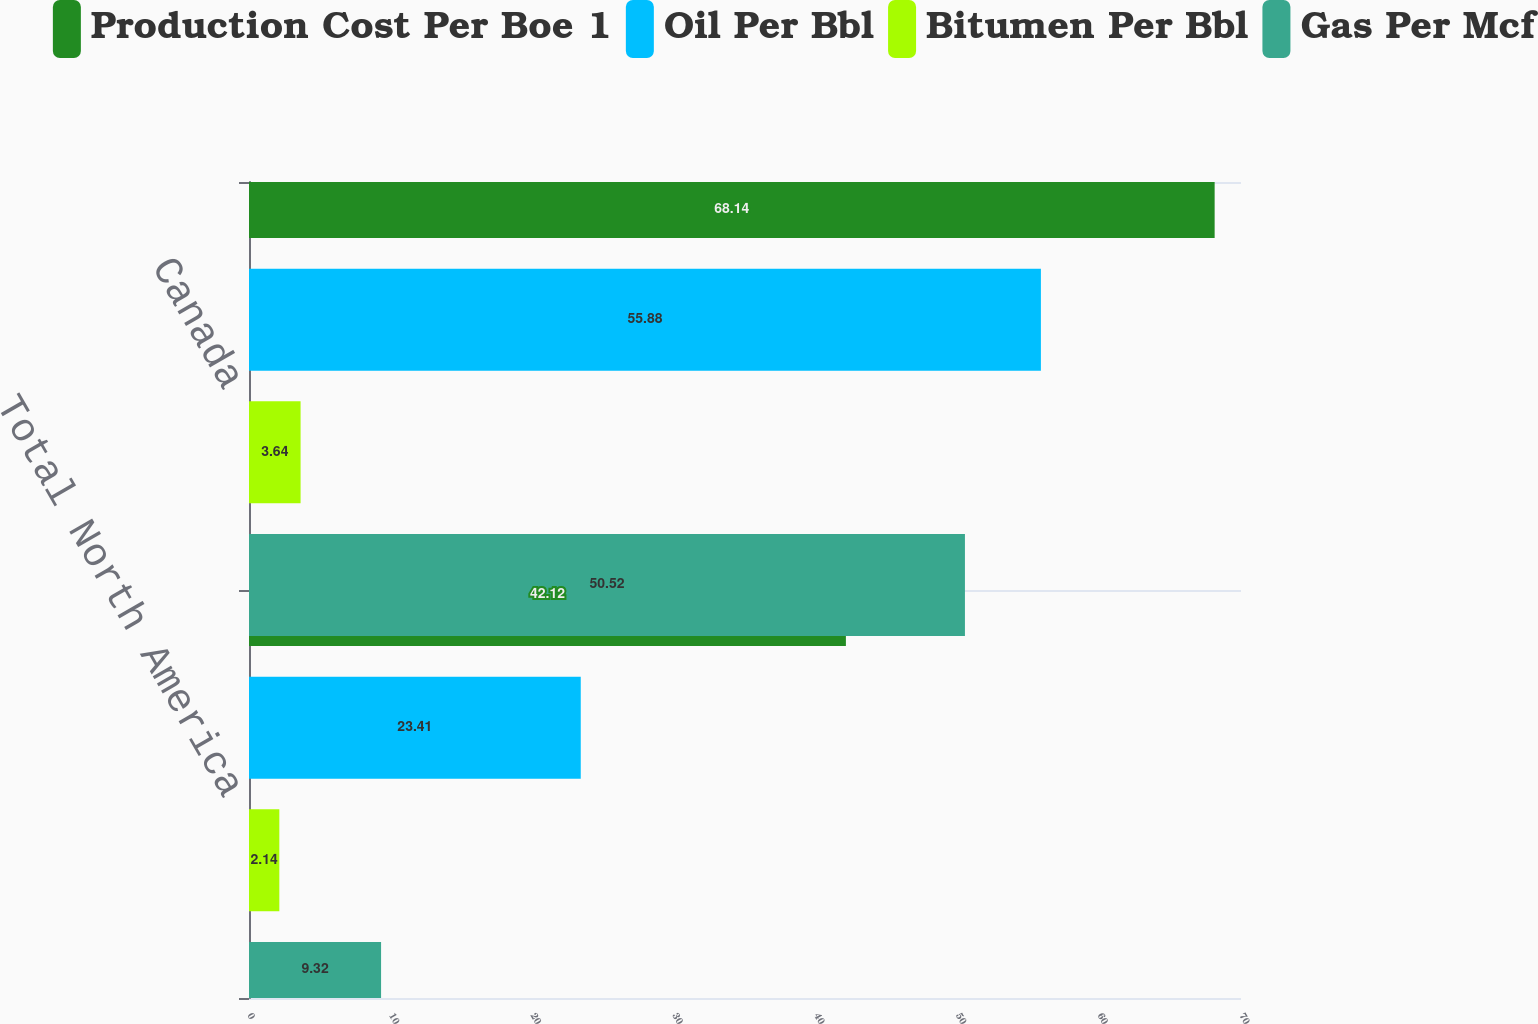Convert chart to OTSL. <chart><loc_0><loc_0><loc_500><loc_500><stacked_bar_chart><ecel><fcel>Total North America<fcel>Canada<nl><fcel>Production Cost Per Boe 1<fcel>42.12<fcel>68.14<nl><fcel>Oil Per Bbl<fcel>23.41<fcel>55.88<nl><fcel>Bitumen Per Bbl<fcel>2.14<fcel>3.64<nl><fcel>Gas Per Mcf<fcel>9.32<fcel>50.52<nl></chart> 